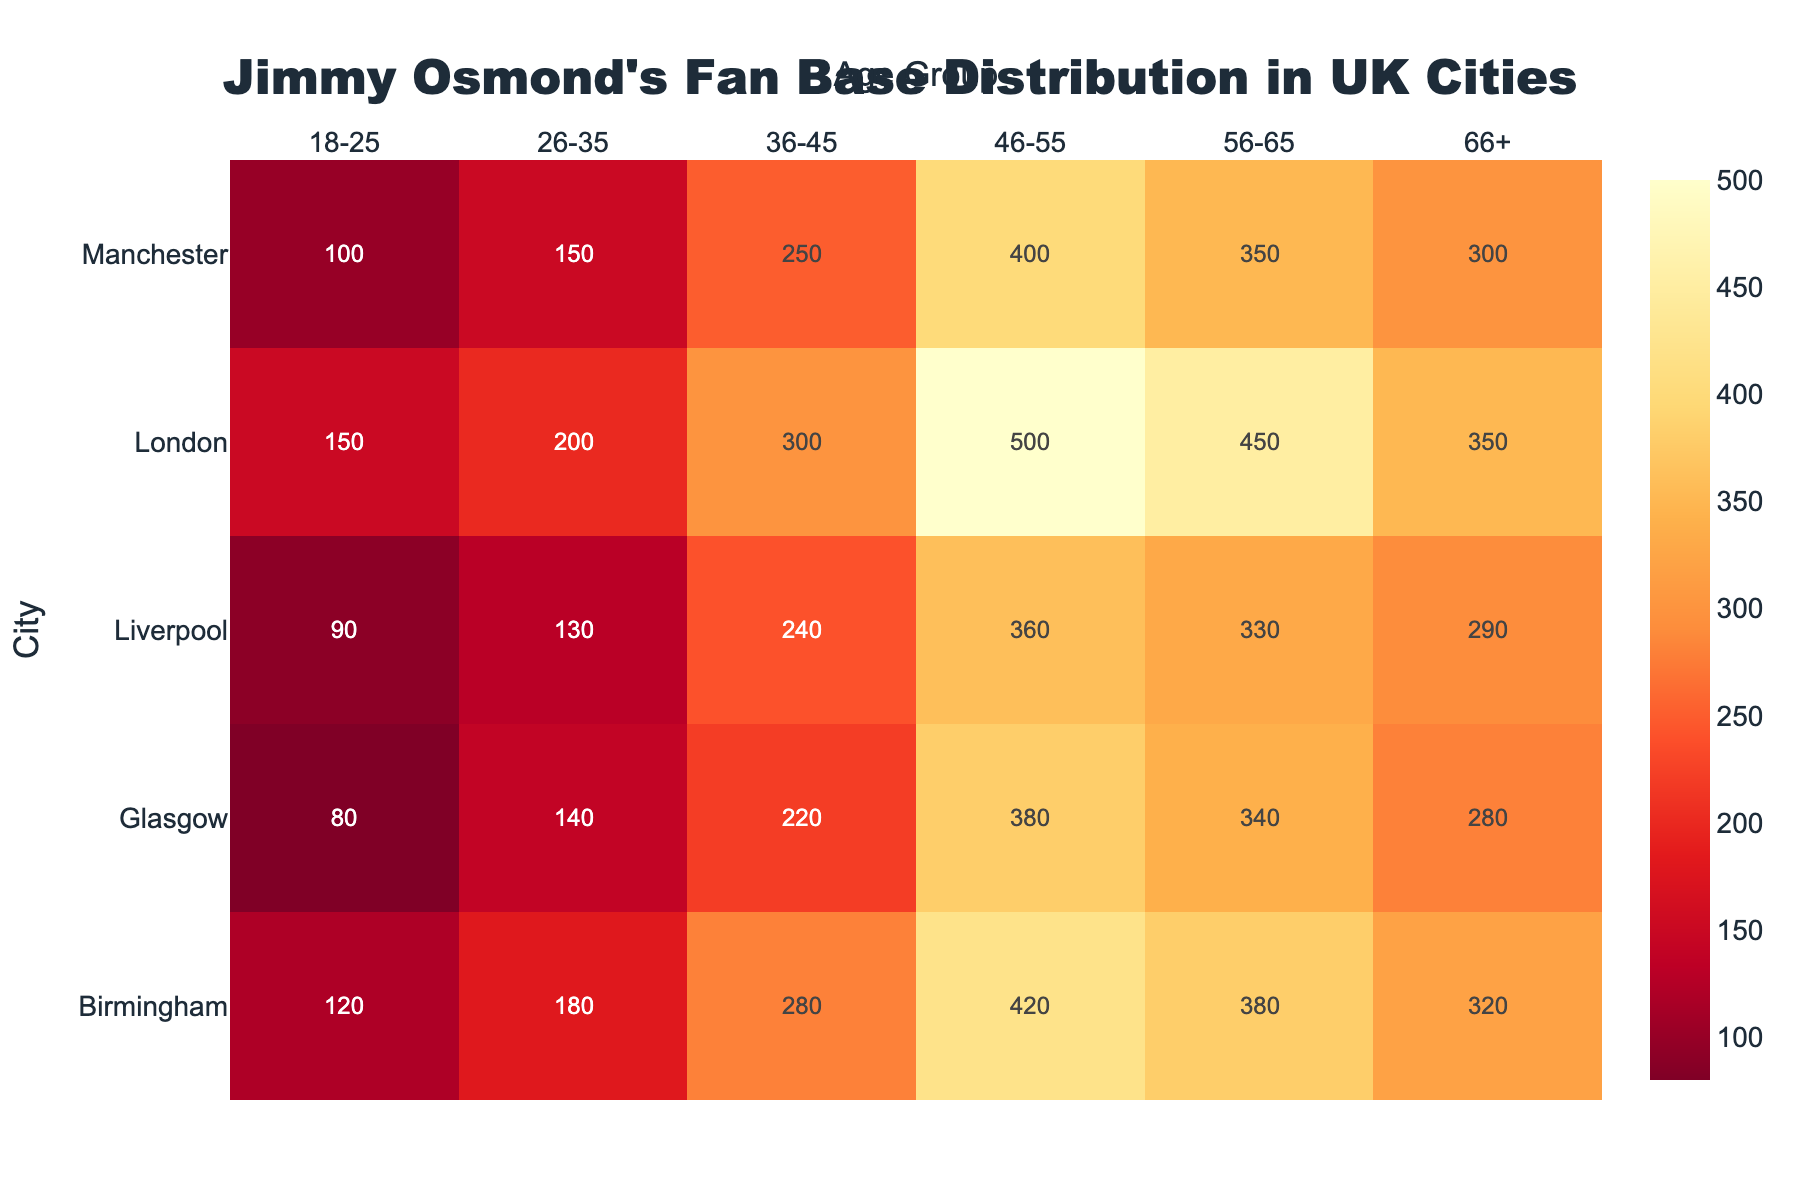What's the title of the Heatmap? The title of the figure is displayed prominently at the top, center-aligned with a larger and bolder font size compared to other text elements. Simply read the title text to find the answer.
Answer: Jimmy Osmond's Fan Base Distribution in UK Cities Which city has the highest number of fans in the 46-55 age group? To find the city with the highest number of fans in the 46-55 age group, locate the column labeled '46-55'. Then, identify the city with the highest value in that column.
Answer: London Among all age groups in Manchester, which one has the lowest number of fans? Focus on Manchester and compare the values for each age group. The lowest value in that row represents the age group with the least number of fans.
Answer: 18-25 How many fans aged 56-65 are there in Glasgow? Look at the row labeled 'Glasgow' and find the corresponding value under the '56-65' column. This value indicates the number of fans in the 56-65 age group.
Answer: 340 What is the total number of fans listed in the heatmap for Liverpool? Sum the values of all age groups for the city of Liverpool by adding each number corresponding to Liverpool.
Answer: 1440 Which age group has the highest number of fans across all cities? Compare the total number of fans for each age group by summing the respective columns across all cities. Identify the age group with the highest sum.
Answer: 46-55 What is the average number of fans in the 36-45 age group across all cities? Calculate the average by adding the values of the 36-45 age group for all cities and then dividing the sum by the number of cities (5).
Answer: 258 In which city do fans age 66+ outnumber fans aged 56-65? Compare the number of fans in the 66+ and 56-65 age groups for each city. Identify the city where the 66+ group is greater than the 56-65 group.
Answer: None What is the total number of fans aged between 26-45 in Birmingham? Add the values of the 26-35 and 36-45 age groups for Birmingham. This gives the number of fans aged between 26-45 in Birmingham.
Answer: 460 